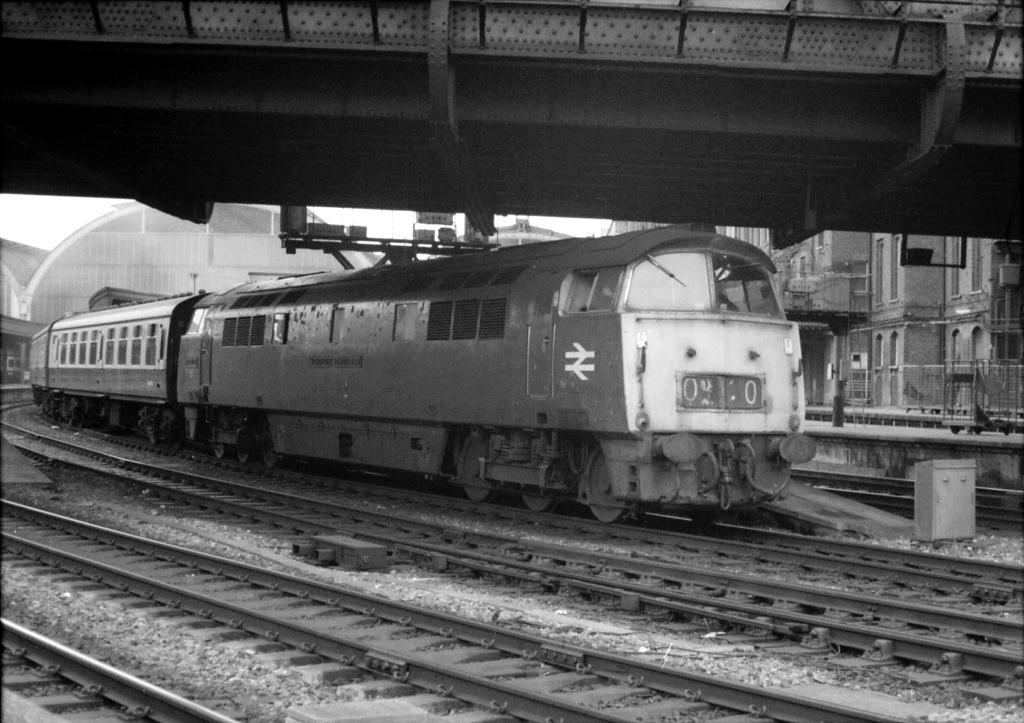What is the main subject of the image? There is a train in the image. Where is the train located? The train is on a railway track. What can be seen in the background of the image? There are buildings in the background of the image. How many cups of coffee are being served on the train in the image? There is no information about cups of coffee or any other food or beverage being served on the train in the image. 